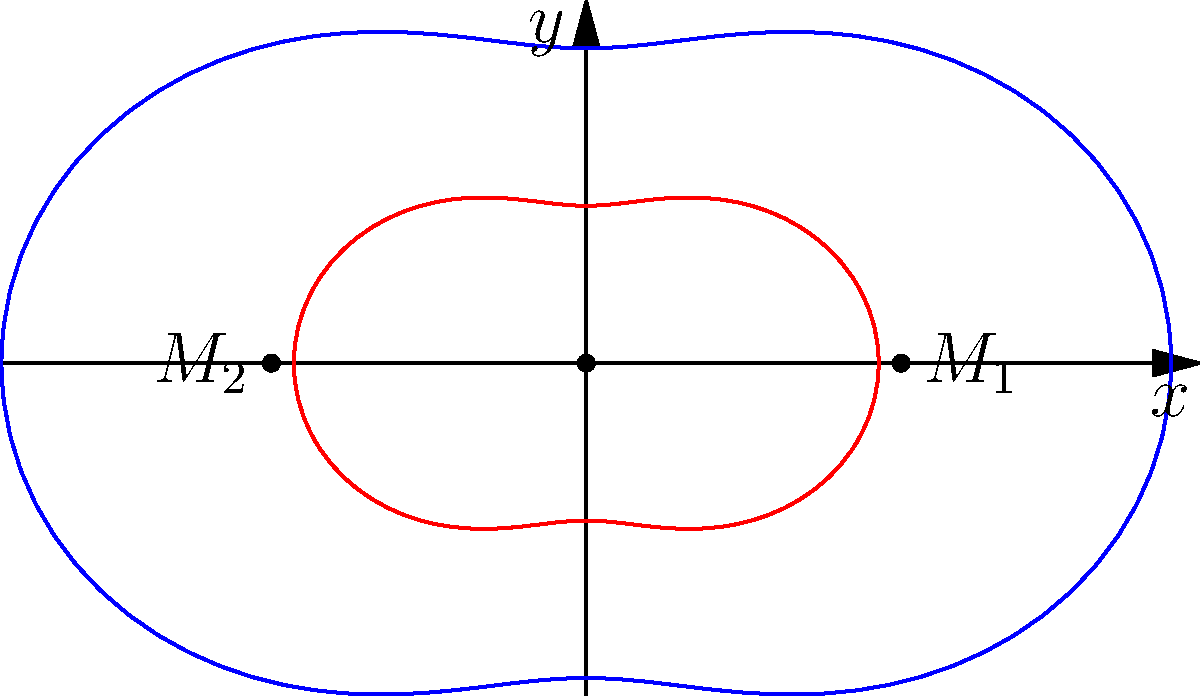Consider a binary star system with masses $M_1$ and $M_2$ located at $(a,0)$ and $(-a,0)$ respectively in a polar coordinate system. The shape of a gravitational equipotential surface around this system can be approximated by the equation:

$$r(\theta) = k(1 + \epsilon \cos(2\theta))$$

Where $k$ and $\epsilon$ are constants related to the system's properties. Given the diagram, which shows two such surfaces (blue and red), what physical interpretation can be given to the parameter $\epsilon$, and how does it relate to the masses of the stars? To interpret the parameter $\epsilon$, let's analyze the equation and the diagram step-by-step:

1) The equation $r(\theta) = k(1 + \epsilon \cos(2\theta))$ describes a closed curve in polar coordinates.

2) When $\epsilon = 0$, the equation reduces to $r(\theta) = k$, which is a circle. This represents the case where the gravitational influence of both stars is equal.

3) As $\epsilon$ increases, the curve becomes more distorted from a circular shape. In the diagram, we see two curves: a blue (outer) one and a red (inner) one.

4) The distortion is most pronounced along the x-axis, where the stars are located. The curve bulges out towards each star.

5) The parameter $\epsilon$ controls the magnitude of this distortion. A larger $\epsilon$ results in a more pronounced bulge.

6) Physically, this distortion represents the relative influence of each star on the gravitational field. 

7) If the masses of the stars were equal, the distortion would be symmetric. However, if one star is more massive than the other, it will create a stronger gravitational pull, resulting in a larger bulge on its side.

8) Therefore, $\epsilon$ is related to the mass ratio of the two stars. A larger $\epsilon$ indicates a greater difference in masses between $M_1$ and $M_2$.

9) Mathematically, $\epsilon$ is proportional to $(M_1 - M_2)/(M_1 + M_2)$.

In conclusion, $\epsilon$ represents the asymmetry in the gravitational field due to the difference in masses of the two stars. It's a measure of the system's deviation from a perfectly symmetric binary system.
Answer: $\epsilon$ represents mass asymmetry, proportional to $(M_1 - M_2)/(M_1 + M_2)$. 